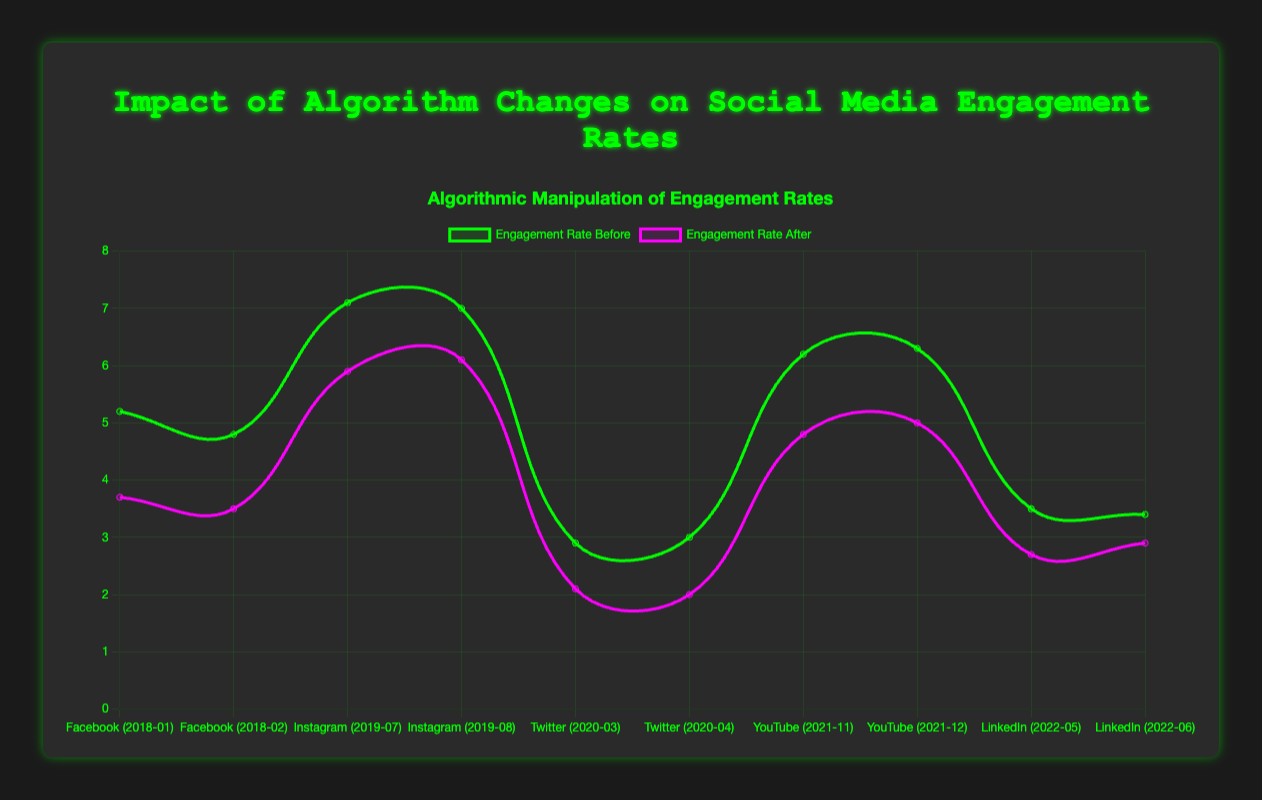Who experienced the largest drop in engagement rate after an algorithm change? To find the largest drop, subtract the "engagementRateAfter" from the "engagementRateBefore" for each data point and find the maximum difference. For Facebook's News Feed Update in 2018 (January): 5.2 - 3.7 = 1.5, Instagram's Explore Tab Update in 2019 (July): 7.1 - 5.9 = 1.2, Twitter's Home Timeline Update in 2020 (March): 2.9 - 2.1 = 0.8, YouTube's Recommendation System Update in 2021 (November): 6.2 - 4.8 = 1.4, LinkedIn's Content Distribution Update in 2022 (May): 3.5 - 2.7 = 0.8. Facebook in January 2018 had the largest drop of 1.5.
Answer: Facebook in January 2018 Which platform had an increase in engagement rate after the algorithm change? Check the "engagementRateBefore" and "engagementRateAfter" values of all data points. If "engagementRateAfter" is greater than "engagementRateBefore," there is an increase. None of the given data points have "engagementRateAfter" greater than "engagementRateBefore."
Answer: None Among Instagram and YouTube, which month experienced the least decrease in engagement rate after their respective updates? For Instagram (July and August 2019): 7.1 - 5.9 = 1.2, 7.0 - 6.1 = 0.9. For YouTube (November and December 2021): 6.2 - 4.8 = 1.4, 6.3 - 5.0 = 1.3. The least decrease is 0.9 in Instagram August 2019.
Answer: Instagram August 2019 What was the average engagement rate before the algorithm change for Facebook and Twitter? Find the average by adding "engagementRateBefore" and dividing by the count. Facebook: (5.2 + 4.8) / 2 = 5.0, Twitter: (2.9 + 3.0) / 2 = 2.95. The total is (5.0 + 2.95) / 2 = 3.975.
Answer: 3.975 How many platforms have an engagement rate that dropped below 3.0 after the algorithm change? Count the data points where "engagementRateAfter" is below 3.0. For Facebook (January and February 2018), 3.7 and 3.5 are greater than 3.0, Instagram (July and August 2019): 5.9 and 6.1 are greater than 3.0, Twitter (March and April 2020): 2.1, 2.0 are below 3.0, YouTube (November and December 2021): 4.8, 5.0 are greater than 3.0, LinkedIn (May and June 2022): 2.7, 2.9 are below 3.0. Total count is 4 (Twitter and LinkedIn).
Answer: 4 For LinkedIn's Content Distribution Update in 2022, what is the average engagement rate before and after the change? Calculate the average for values in May and June 2022. Before: (3.5 + 3.4) / 2 = 3.45, After: (2.7 + 2.9) / 2 = 2.8.
Answer: Before: 3.45, After: 2.8 